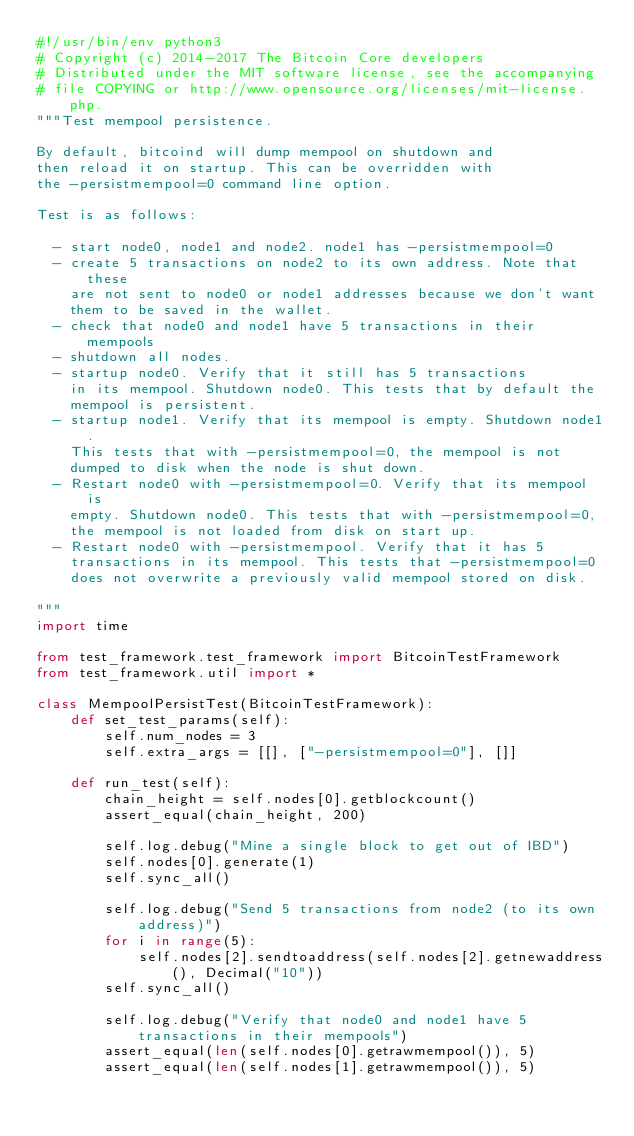<code> <loc_0><loc_0><loc_500><loc_500><_Python_>#!/usr/bin/env python3
# Copyright (c) 2014-2017 The Bitcoin Core developers
# Distributed under the MIT software license, see the accompanying
# file COPYING or http://www.opensource.org/licenses/mit-license.php.
"""Test mempool persistence.

By default, bitcoind will dump mempool on shutdown and
then reload it on startup. This can be overridden with
the -persistmempool=0 command line option.

Test is as follows:

  - start node0, node1 and node2. node1 has -persistmempool=0
  - create 5 transactions on node2 to its own address. Note that these
    are not sent to node0 or node1 addresses because we don't want
    them to be saved in the wallet.
  - check that node0 and node1 have 5 transactions in their mempools
  - shutdown all nodes.
  - startup node0. Verify that it still has 5 transactions
    in its mempool. Shutdown node0. This tests that by default the
    mempool is persistent.
  - startup node1. Verify that its mempool is empty. Shutdown node1.
    This tests that with -persistmempool=0, the mempool is not
    dumped to disk when the node is shut down.
  - Restart node0 with -persistmempool=0. Verify that its mempool is
    empty. Shutdown node0. This tests that with -persistmempool=0,
    the mempool is not loaded from disk on start up.
  - Restart node0 with -persistmempool. Verify that it has 5
    transactions in its mempool. This tests that -persistmempool=0
    does not overwrite a previously valid mempool stored on disk.

"""
import time

from test_framework.test_framework import BitcoinTestFramework
from test_framework.util import *

class MempoolPersistTest(BitcoinTestFramework):
    def set_test_params(self):
        self.num_nodes = 3
        self.extra_args = [[], ["-persistmempool=0"], []]

    def run_test(self):
        chain_height = self.nodes[0].getblockcount()
        assert_equal(chain_height, 200)

        self.log.debug("Mine a single block to get out of IBD")
        self.nodes[0].generate(1)
        self.sync_all()

        self.log.debug("Send 5 transactions from node2 (to its own address)")
        for i in range(5):
            self.nodes[2].sendtoaddress(self.nodes[2].getnewaddress(), Decimal("10"))
        self.sync_all()

        self.log.debug("Verify that node0 and node1 have 5 transactions in their mempools")
        assert_equal(len(self.nodes[0].getrawmempool()), 5)
        assert_equal(len(self.nodes[1].getrawmempool()), 5)
</code> 